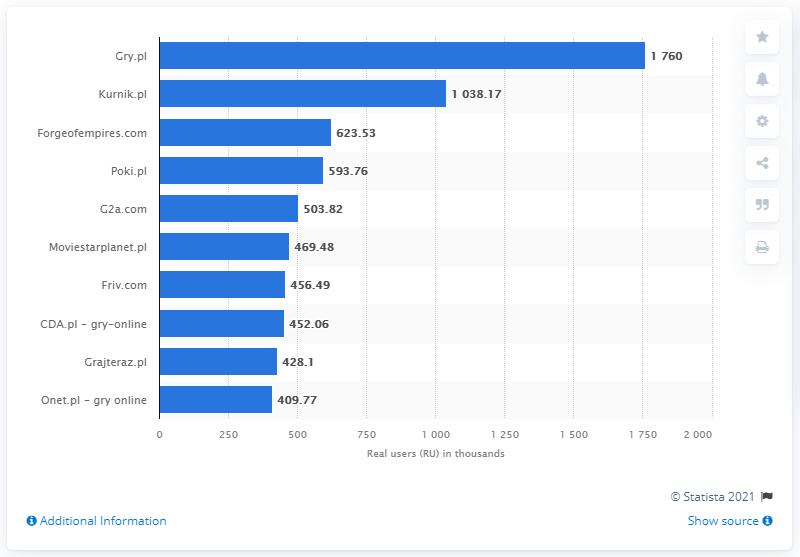What was the leading website for online games in Poland in February 2020?
 Gry.pl 